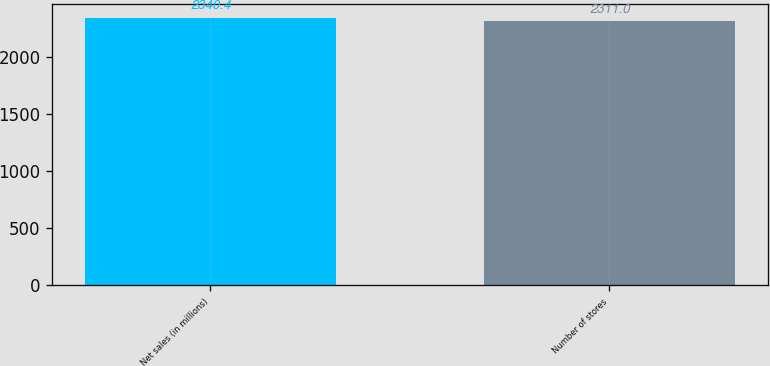Convert chart to OTSL. <chart><loc_0><loc_0><loc_500><loc_500><bar_chart><fcel>Net sales (in millions)<fcel>Number of stores<nl><fcel>2340.4<fcel>2311<nl></chart> 